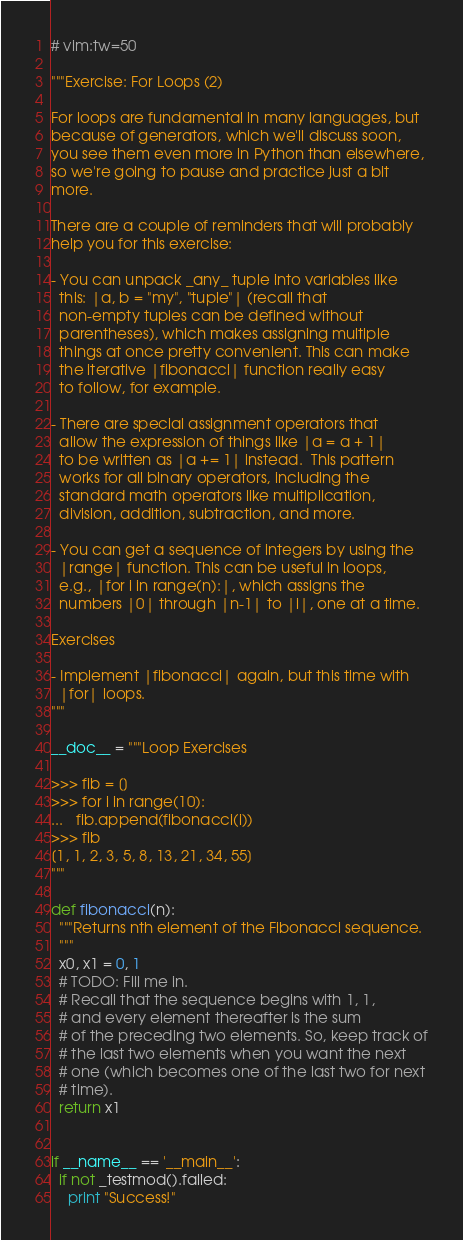<code> <loc_0><loc_0><loc_500><loc_500><_Python_># vim:tw=50

"""Exercise: For Loops (2)

For loops are fundamental in many languages, but
because of generators, which we'll discuss soon,
you see them even more in Python than elsewhere,
so we're going to pause and practice just a bit
more.

There are a couple of reminders that will probably
help you for this exercise:

- You can unpack _any_ tuple into variables like
  this: |a, b = "my", "tuple"| (recall that
  non-empty tuples can be defined without
  parentheses), which makes assigning multiple
  things at once pretty convenient. This can make
  the iterative |fibonacci| function really easy
  to follow, for example.

- There are special assignment operators that
  allow the expression of things like |a = a + 1|
  to be written as |a += 1| instead.  This pattern
  works for all binary operators, including the
  standard math operators like multiplication,
  division, addition, subtraction, and more.

- You can get a sequence of integers by using the
  |range| function. This can be useful in loops,
  e.g., |for i in range(n):|, which assigns the
  numbers |0| through |n-1| to |i|, one at a time.

Exercises

- Implement |fibonacci| again, but this time with
  |for| loops.
"""

__doc__ = """Loop Exercises

>>> fib = []
>>> for i in range(10):
...   fib.append(fibonacci(i))
>>> fib
[1, 1, 2, 3, 5, 8, 13, 21, 34, 55]
"""

def fibonacci(n):
  """Returns nth element of the Fibonacci sequence.
  """
  x0, x1 = 0, 1
  # TODO: Fill me in.
  # Recall that the sequence begins with 1, 1,
  # and every element thereafter is the sum
  # of the preceding two elements. So, keep track of
  # the last two elements when you want the next
  # one (which becomes one of the last two for next
  # time).
  return x1


if __name__ == '__main__':
  if not _testmod().failed:
    print "Success!"
</code> 